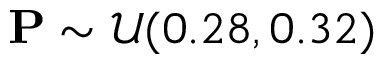Convert formula to latex. <formula><loc_0><loc_0><loc_500><loc_500>P \sim \mathcal { U } ( 0 . 2 8 , 0 . 3 2 )</formula> 